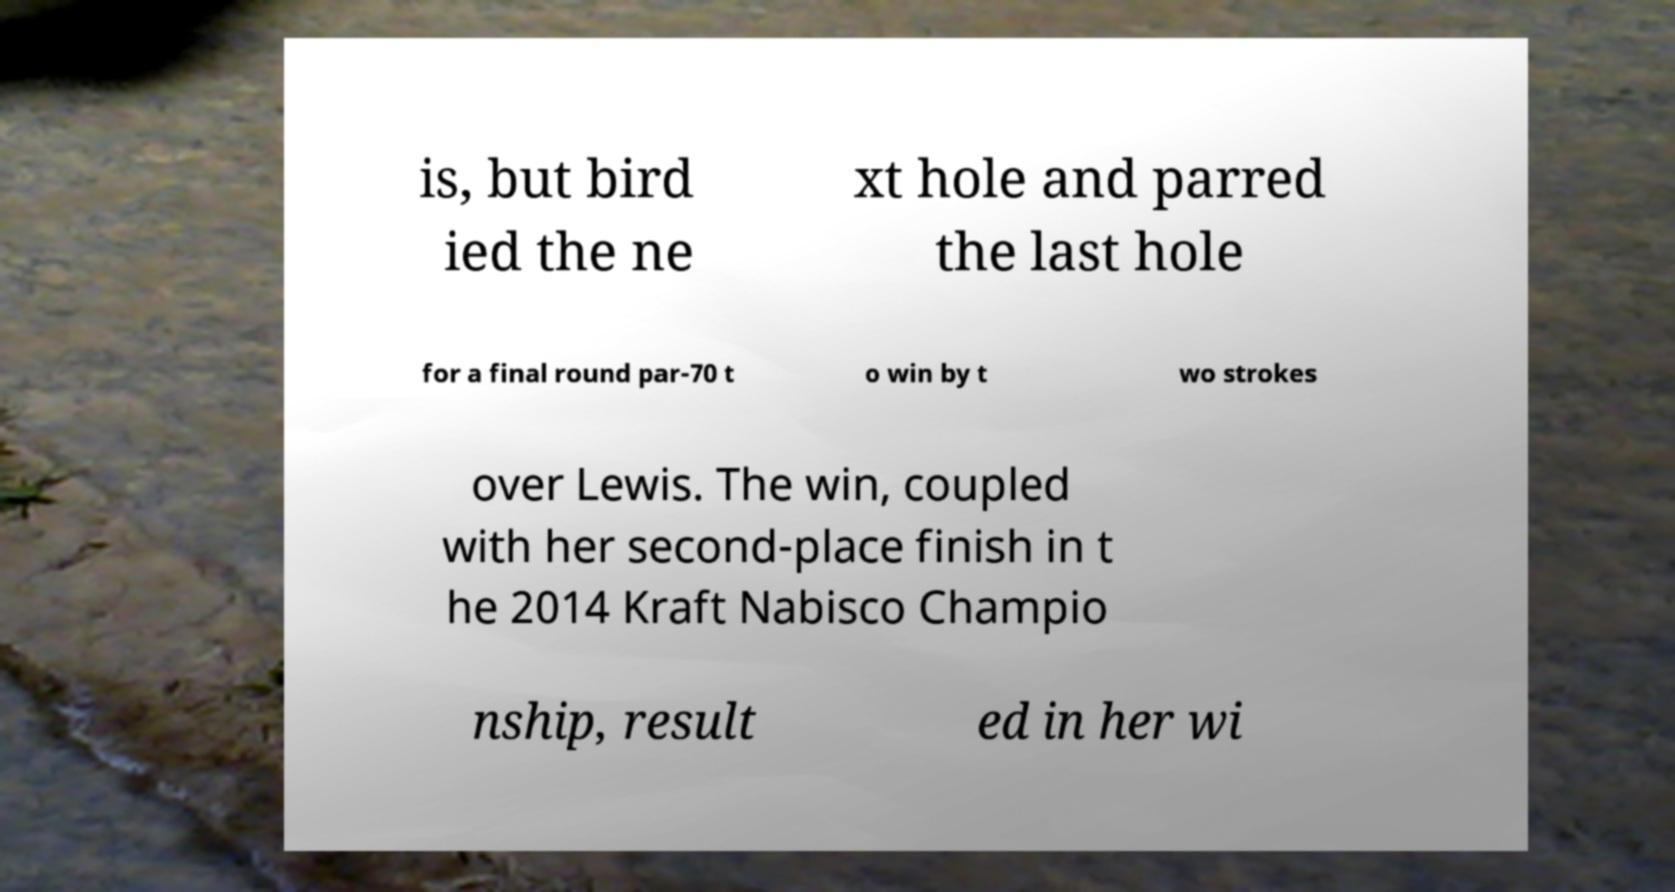Please read and relay the text visible in this image. What does it say? is, but bird ied the ne xt hole and parred the last hole for a final round par-70 t o win by t wo strokes over Lewis. The win, coupled with her second-place finish in t he 2014 Kraft Nabisco Champio nship, result ed in her wi 